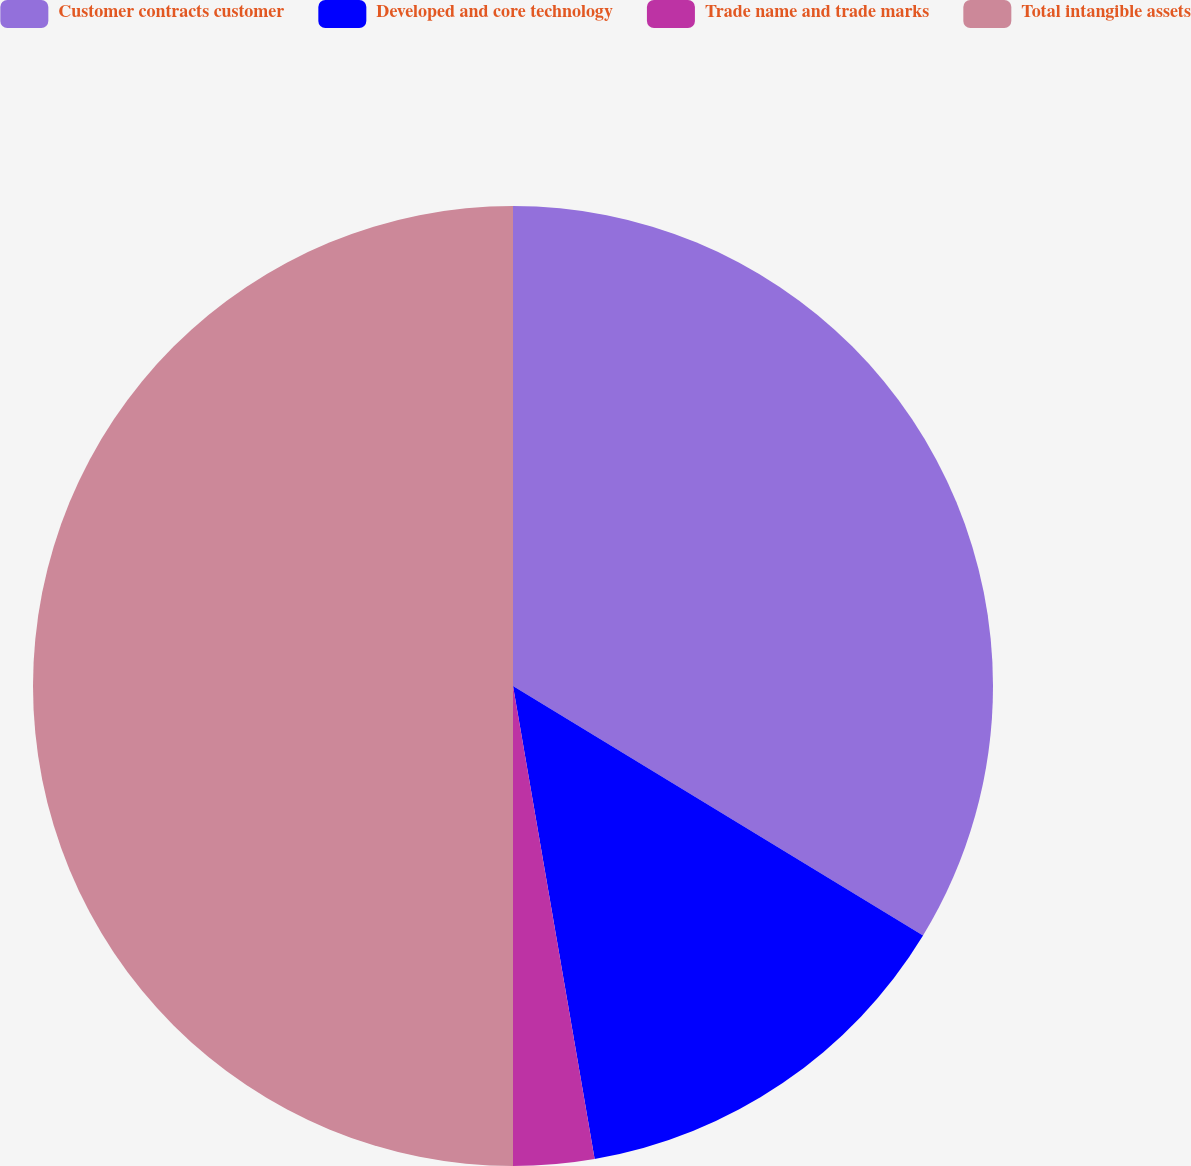<chart> <loc_0><loc_0><loc_500><loc_500><pie_chart><fcel>Customer contracts customer<fcel>Developed and core technology<fcel>Trade name and trade marks<fcel>Total intangible assets<nl><fcel>33.7%<fcel>13.58%<fcel>2.72%<fcel>50.0%<nl></chart> 